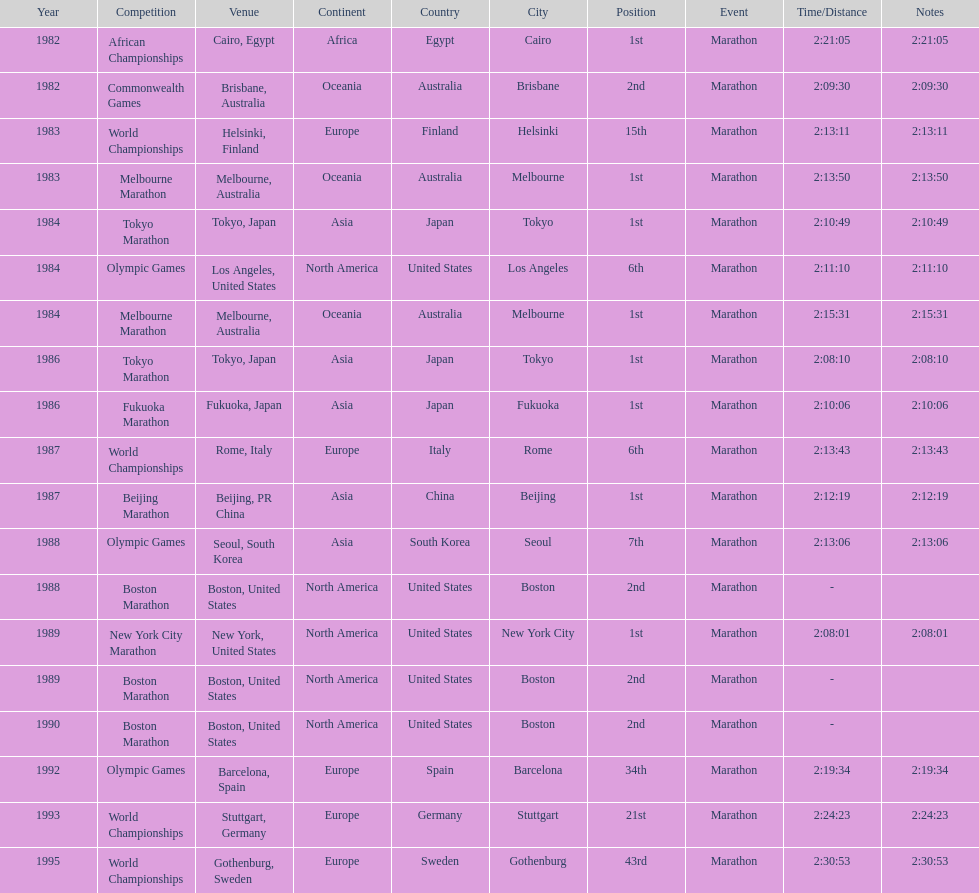What was the first marathon juma ikangaa won? 1982 African Championships. 